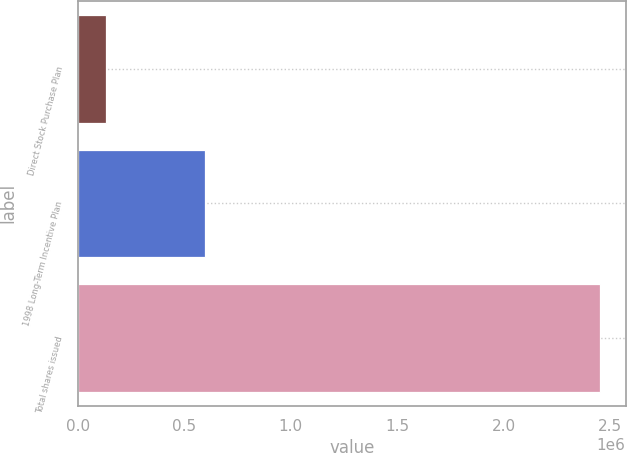Convert chart to OTSL. <chart><loc_0><loc_0><loc_500><loc_500><bar_chart><fcel>Direct Stock Purchase Plan<fcel>1998 Long-Term Incentive Plan<fcel>Total shares issued<nl><fcel>133133<fcel>598439<fcel>2.45174e+06<nl></chart> 